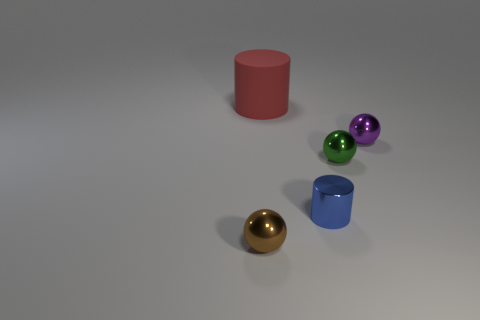There is a tiny object left of the cylinder behind the purple metallic object; what is it made of?
Offer a terse response. Metal. Do the cylinder on the right side of the big red cylinder and the red cylinder have the same material?
Give a very brief answer. No. There is a matte cylinder that is behind the green shiny thing; how big is it?
Offer a terse response. Large. There is a tiny green shiny sphere in front of the red thing; is there a shiny cylinder behind it?
Your answer should be very brief. No. Do the tiny thing to the left of the red cylinder and the cylinder that is on the left side of the blue thing have the same color?
Give a very brief answer. No. The metallic cylinder is what color?
Offer a very short reply. Blue. Are there any other things that have the same color as the large thing?
Provide a succinct answer. No. What color is the thing that is both behind the blue shiny cylinder and left of the tiny blue thing?
Provide a short and direct response. Red. Do the cylinder that is behind the green shiny ball and the metal cylinder have the same size?
Your response must be concise. No. Is the number of tiny brown metal things right of the large red cylinder greater than the number of big cylinders?
Provide a succinct answer. No. 